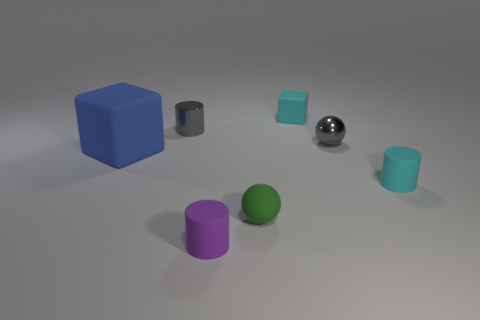Add 1 gray cylinders. How many objects exist? 8 Subtract all cylinders. How many objects are left? 4 Subtract all small objects. Subtract all tiny green balls. How many objects are left? 0 Add 1 small cylinders. How many small cylinders are left? 4 Add 6 tiny gray things. How many tiny gray things exist? 8 Subtract 0 yellow spheres. How many objects are left? 7 